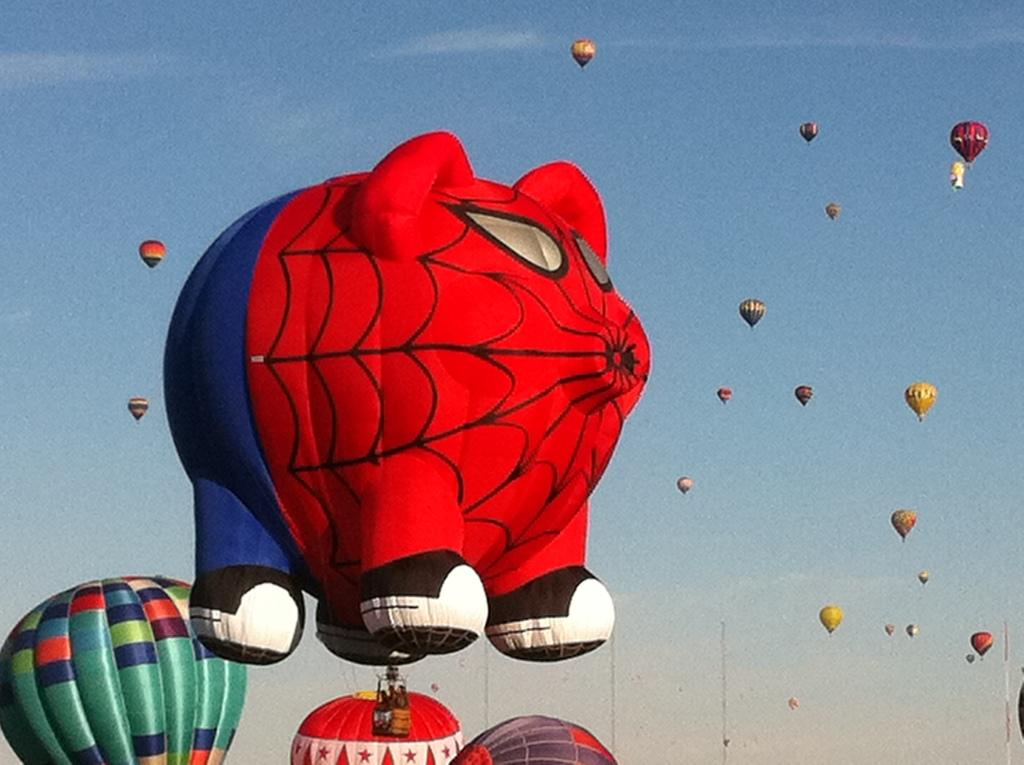What is the main subject of the image? The main subject of the image is hot air balloons. What are the hot air balloons doing in the image? The hot air balloons are flying in the air. How would you describe the sky in the image? The sky is cloudy. Can you see any fairies flying alongside the hot air balloons in the image? There are no fairies present in the image; it only features hot air balloons flying in the sky. 